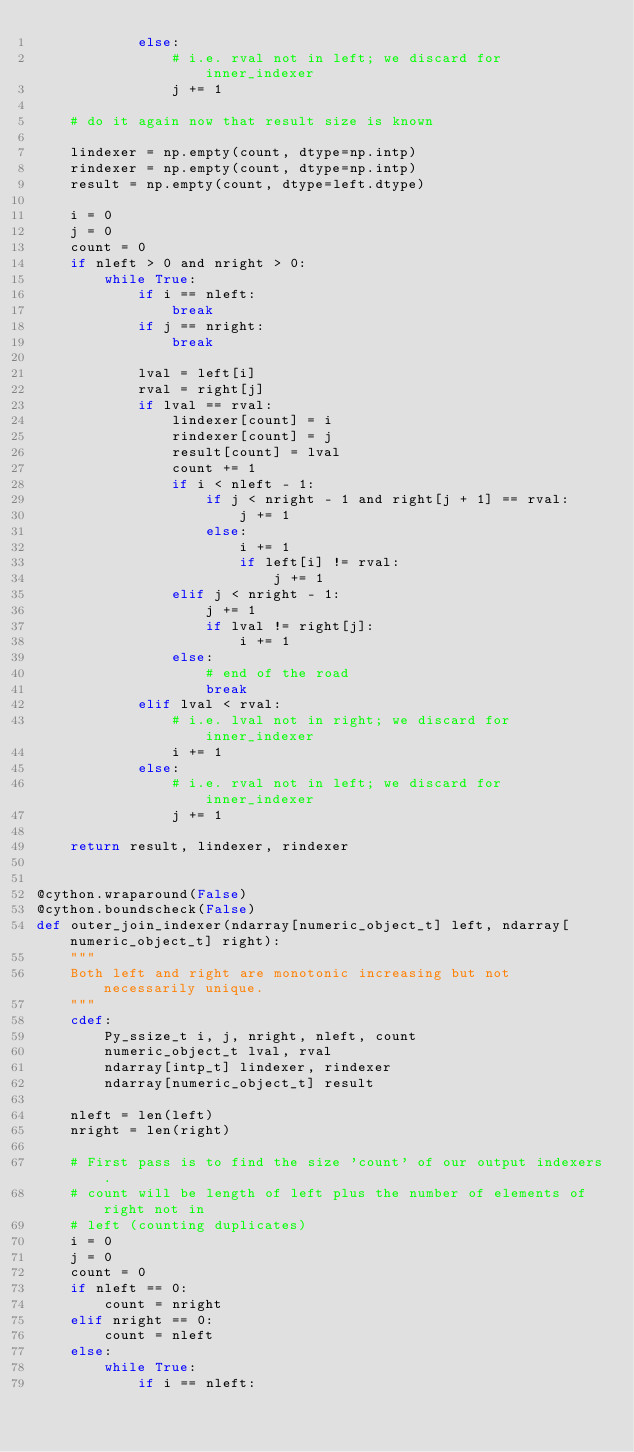Convert code to text. <code><loc_0><loc_0><loc_500><loc_500><_Cython_>            else:
                # i.e. rval not in left; we discard for inner_indexer
                j += 1

    # do it again now that result size is known

    lindexer = np.empty(count, dtype=np.intp)
    rindexer = np.empty(count, dtype=np.intp)
    result = np.empty(count, dtype=left.dtype)

    i = 0
    j = 0
    count = 0
    if nleft > 0 and nright > 0:
        while True:
            if i == nleft:
                break
            if j == nright:
                break

            lval = left[i]
            rval = right[j]
            if lval == rval:
                lindexer[count] = i
                rindexer[count] = j
                result[count] = lval
                count += 1
                if i < nleft - 1:
                    if j < nright - 1 and right[j + 1] == rval:
                        j += 1
                    else:
                        i += 1
                        if left[i] != rval:
                            j += 1
                elif j < nright - 1:
                    j += 1
                    if lval != right[j]:
                        i += 1
                else:
                    # end of the road
                    break
            elif lval < rval:
                # i.e. lval not in right; we discard for inner_indexer
                i += 1
            else:
                # i.e. rval not in left; we discard for inner_indexer
                j += 1

    return result, lindexer, rindexer


@cython.wraparound(False)
@cython.boundscheck(False)
def outer_join_indexer(ndarray[numeric_object_t] left, ndarray[numeric_object_t] right):
    """
    Both left and right are monotonic increasing but not necessarily unique.
    """
    cdef:
        Py_ssize_t i, j, nright, nleft, count
        numeric_object_t lval, rval
        ndarray[intp_t] lindexer, rindexer
        ndarray[numeric_object_t] result

    nleft = len(left)
    nright = len(right)

    # First pass is to find the size 'count' of our output indexers.
    # count will be length of left plus the number of elements of right not in
    # left (counting duplicates)
    i = 0
    j = 0
    count = 0
    if nleft == 0:
        count = nright
    elif nright == 0:
        count = nleft
    else:
        while True:
            if i == nleft:</code> 